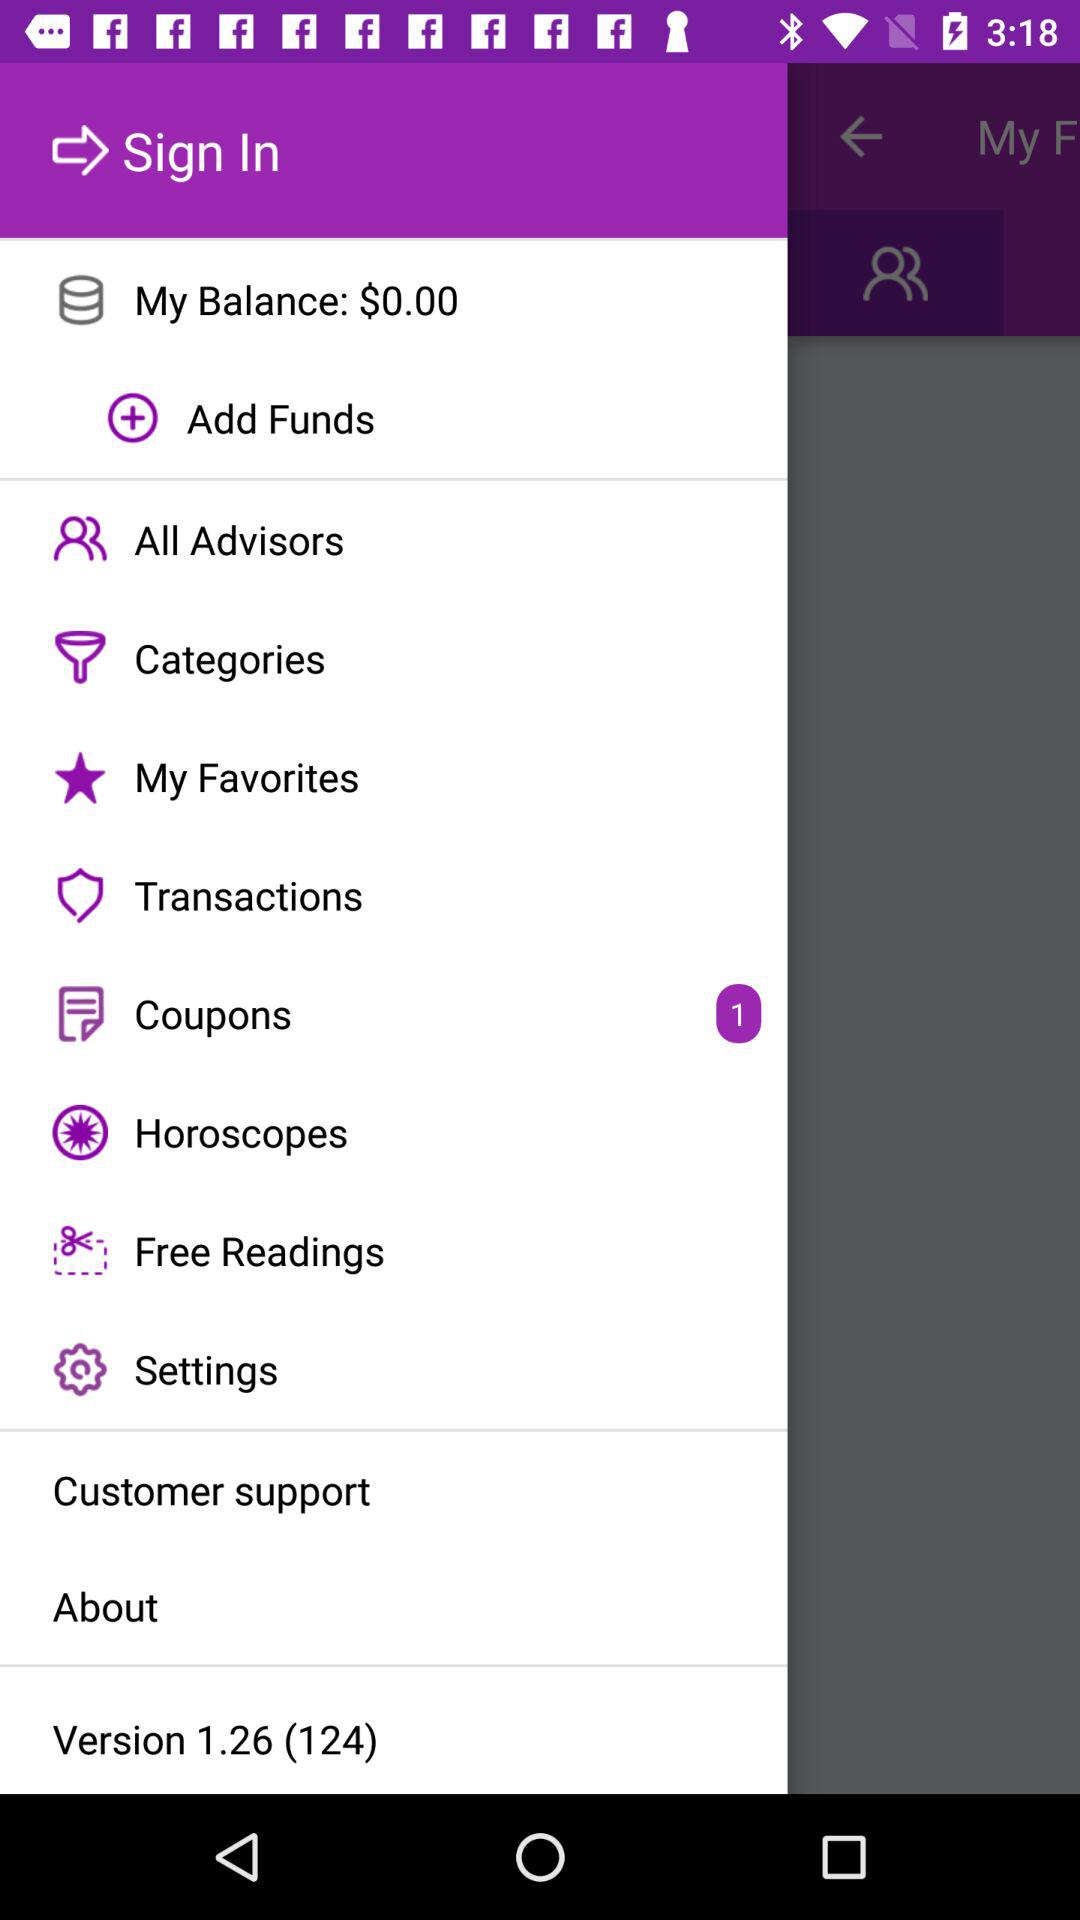How many notifications are there in "Settings"?
When the provided information is insufficient, respond with <no answer>. <no answer> 